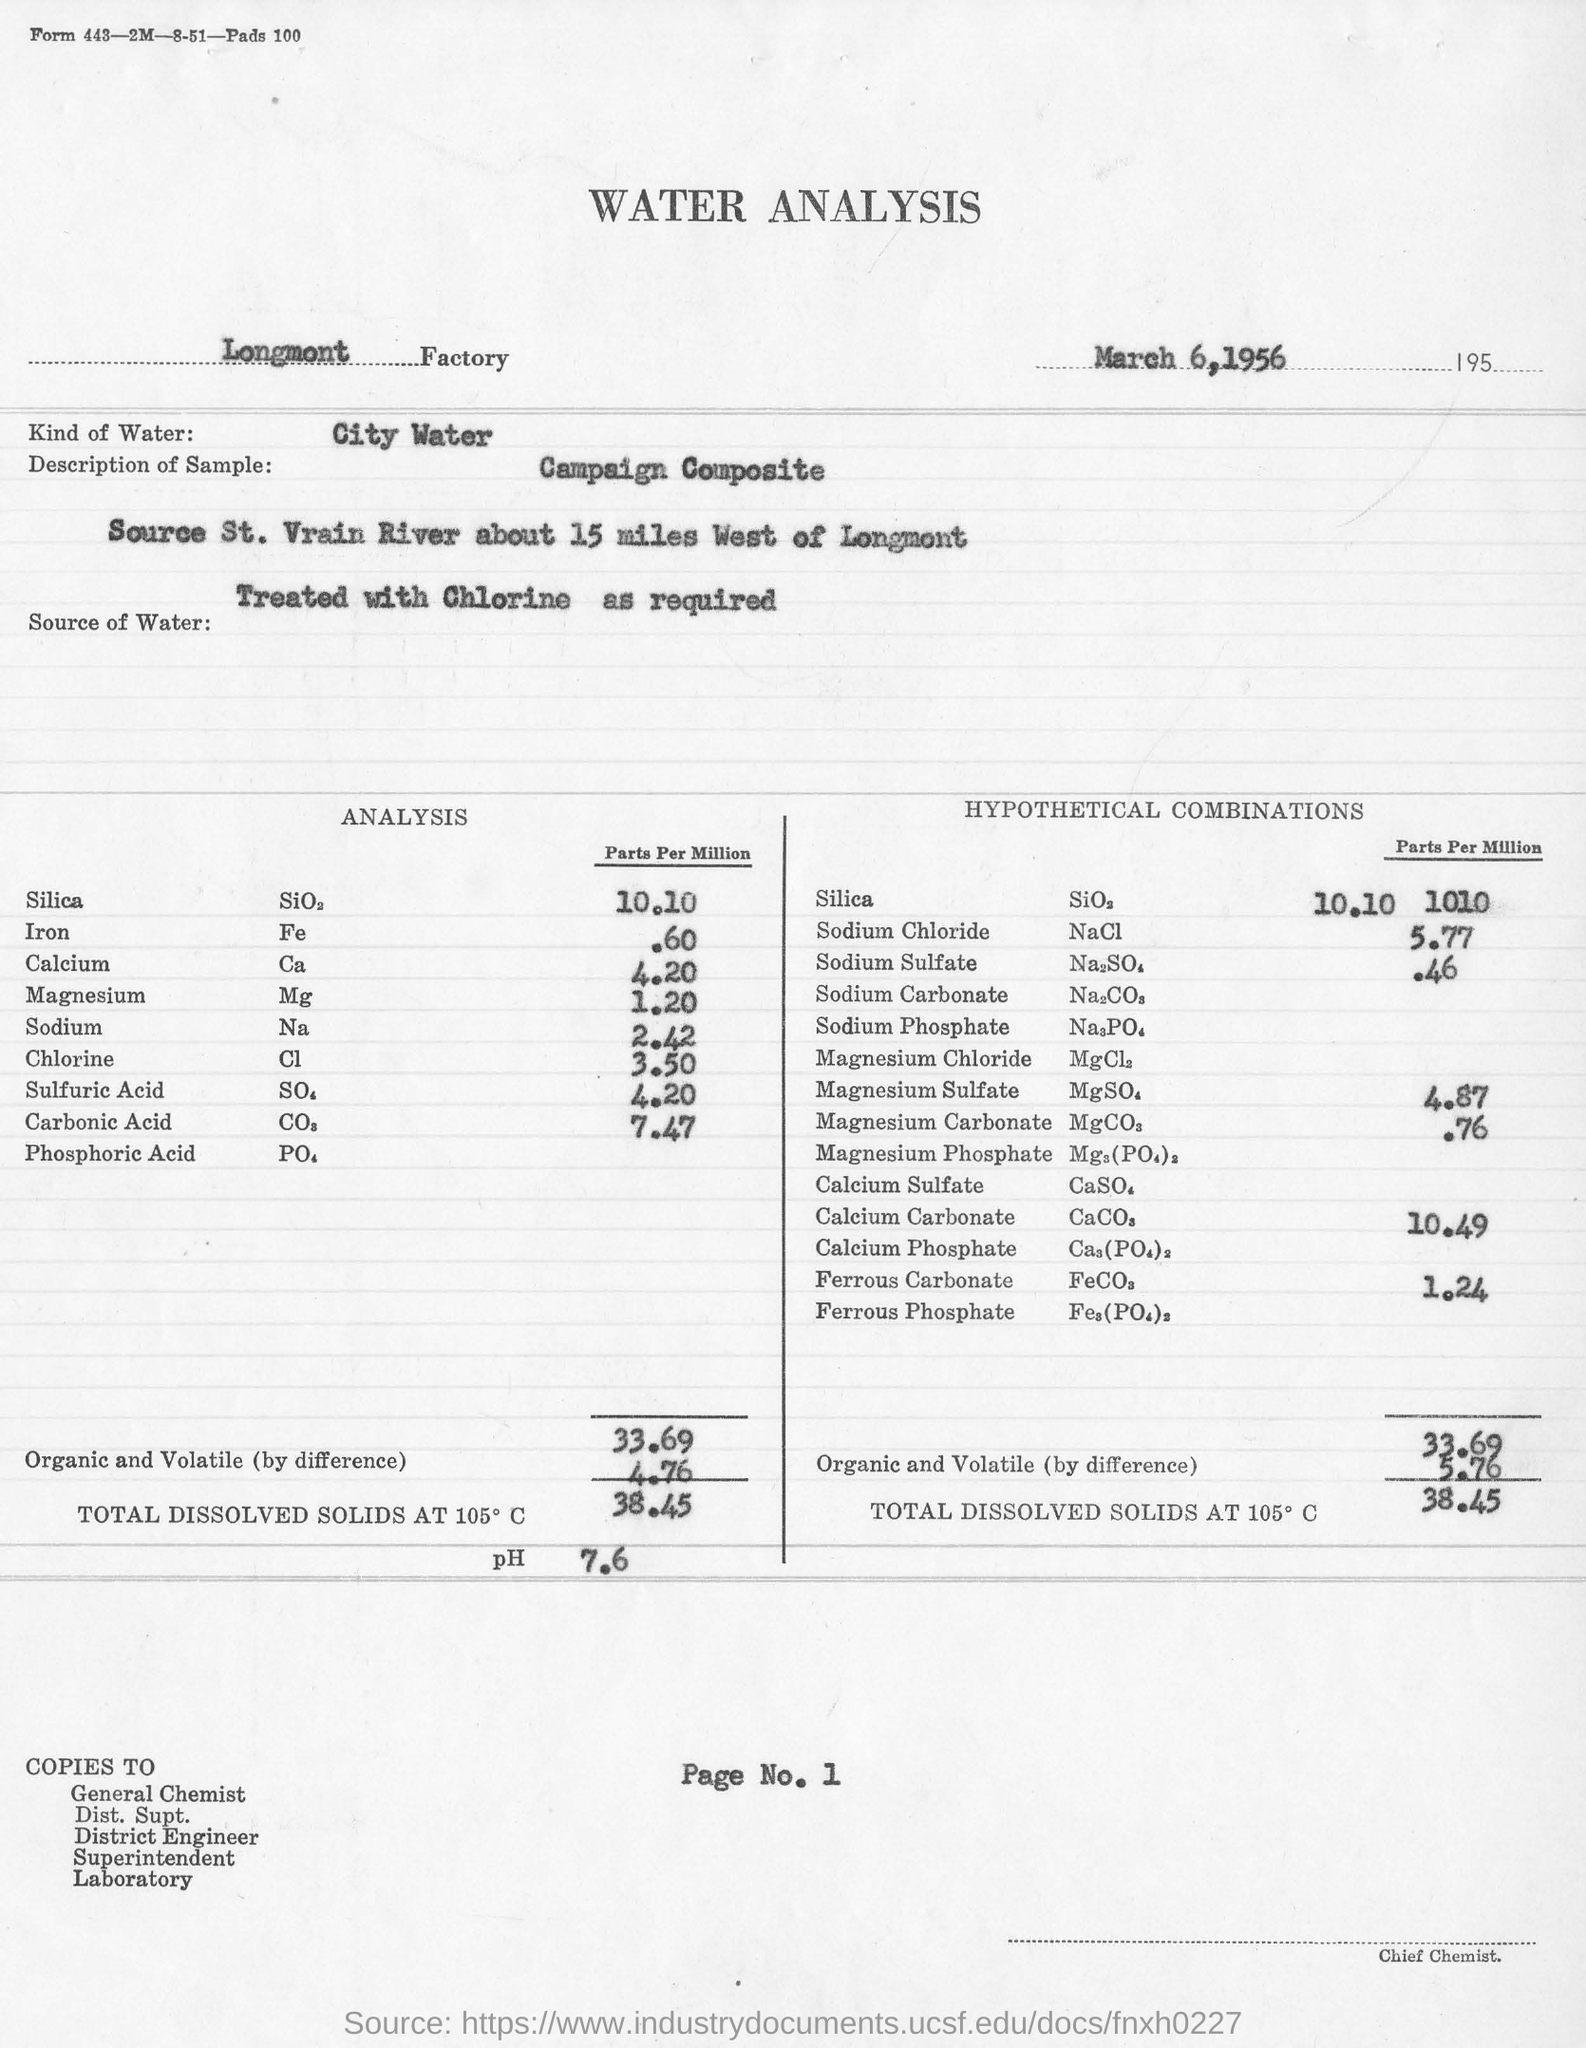What is the factory name ?
Give a very brief answer. Longmont. What is the date mentioned in the document ?
Give a very brief answer. March 6,1956. What is the parts per million analysis for Iron ?
Ensure brevity in your answer.  .60. What is the chemical formula for Chlorine ?
Offer a terse response. Cl. What is the chemical formula for Sodium ?
Provide a short and direct response. Na. What is parts per million analysis for Chlorine ?
Provide a succinct answer. 3.50. What is the parts per million analysis for Sodium ?
Provide a short and direct response. 2.42. What is the chemical formula for Calcium ?
Offer a terse response. Ca. 